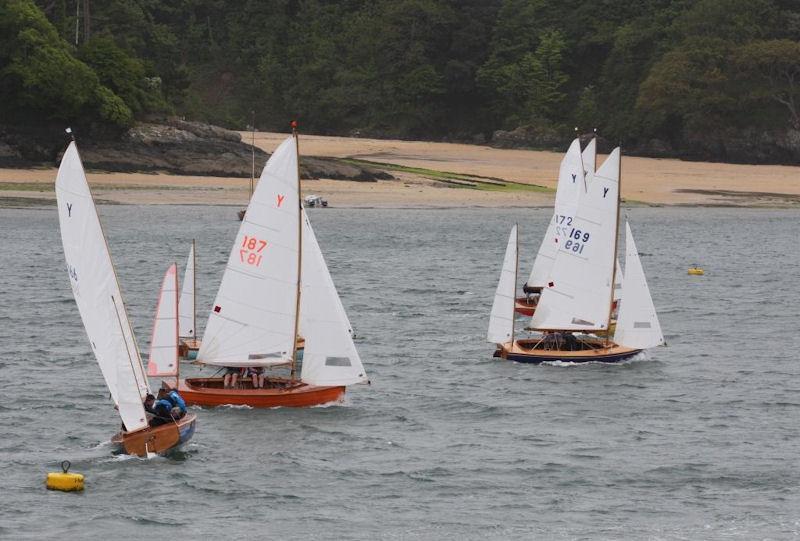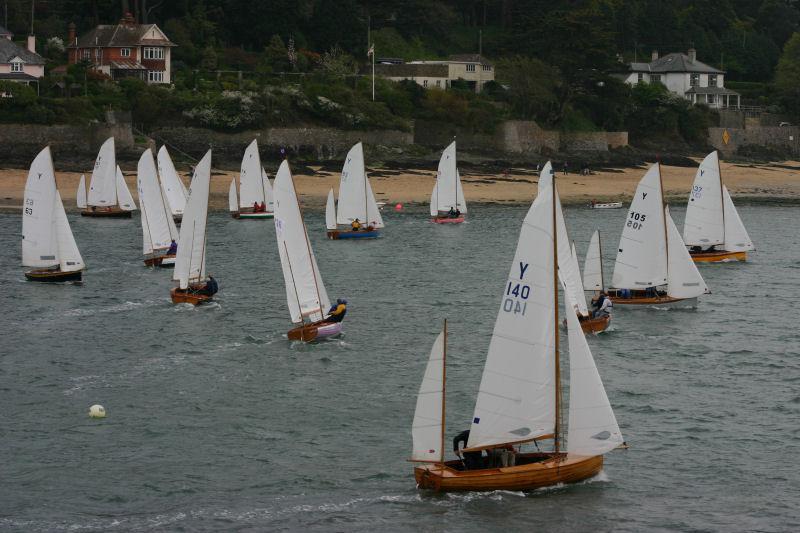The first image is the image on the left, the second image is the image on the right. Considering the images on both sides, is "in at least one image there is a single boat with 3 raised sails" valid? Answer yes or no. No. The first image is the image on the left, the second image is the image on the right. Assess this claim about the two images: "There are at least five boats visible.". Correct or not? Answer yes or no. Yes. 